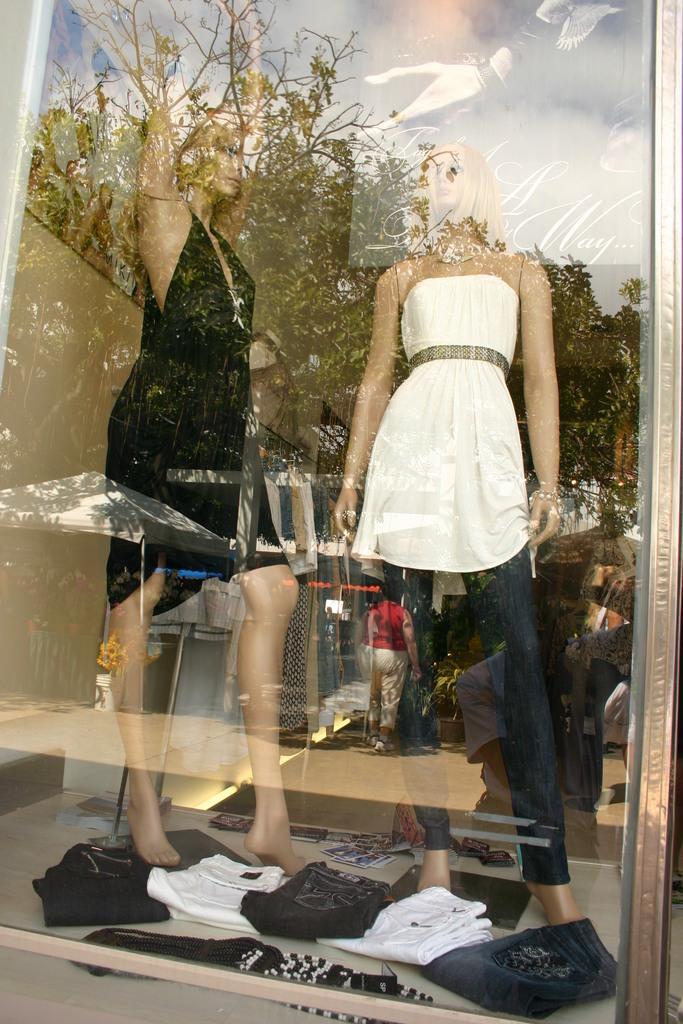Could you give a brief overview of what you see in this image? Through the glass door we can see clothes on the floor and there are two dolls wore dresses and in the background we can see frames on the wall. There are reflections of a tree and a person on the glass door. 